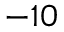<formula> <loc_0><loc_0><loc_500><loc_500>^ { - 1 0 }</formula> 